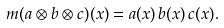<formula> <loc_0><loc_0><loc_500><loc_500>m ( a \otimes b \otimes c ) { ( { x ) } } = a ( { x } ) \, b ( { x } ) \, c ( { x } ) .</formula> 